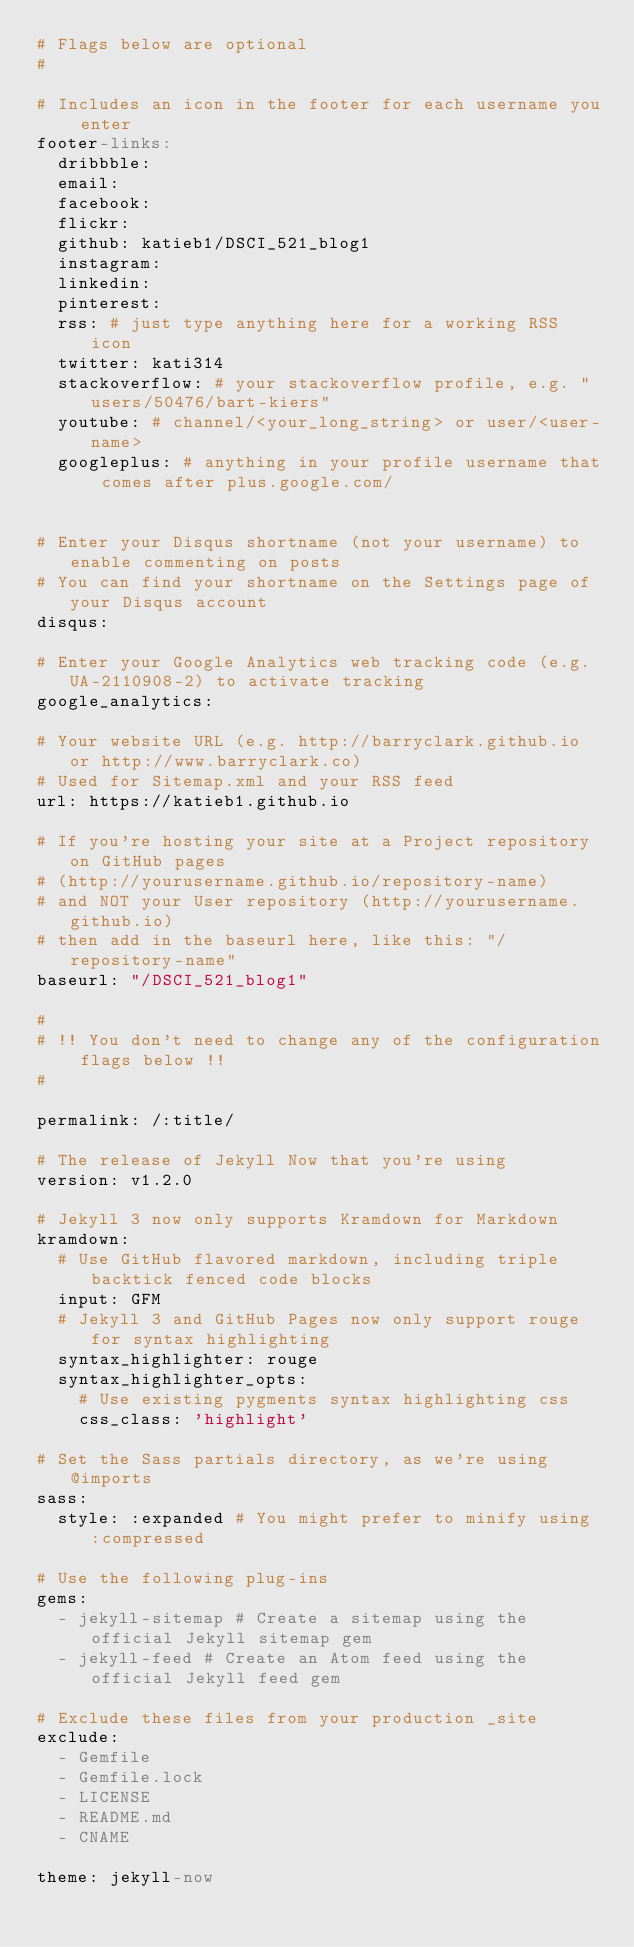<code> <loc_0><loc_0><loc_500><loc_500><_YAML_># Flags below are optional
#

# Includes an icon in the footer for each username you enter
footer-links:
  dribbble:
  email:
  facebook:
  flickr:
  github: katieb1/DSCI_521_blog1
  instagram:
  linkedin:
  pinterest:
  rss: # just type anything here for a working RSS icon
  twitter: kati314
  stackoverflow: # your stackoverflow profile, e.g. "users/50476/bart-kiers"
  youtube: # channel/<your_long_string> or user/<user-name>
  googleplus: # anything in your profile username that comes after plus.google.com/


# Enter your Disqus shortname (not your username) to enable commenting on posts
# You can find your shortname on the Settings page of your Disqus account
disqus:

# Enter your Google Analytics web tracking code (e.g. UA-2110908-2) to activate tracking
google_analytics:

# Your website URL (e.g. http://barryclark.github.io or http://www.barryclark.co)
# Used for Sitemap.xml and your RSS feed
url: https://katieb1.github.io

# If you're hosting your site at a Project repository on GitHub pages
# (http://yourusername.github.io/repository-name)
# and NOT your User repository (http://yourusername.github.io)
# then add in the baseurl here, like this: "/repository-name"
baseurl: "/DSCI_521_blog1"

#
# !! You don't need to change any of the configuration flags below !!
#

permalink: /:title/

# The release of Jekyll Now that you're using
version: v1.2.0

# Jekyll 3 now only supports Kramdown for Markdown
kramdown:
  # Use GitHub flavored markdown, including triple backtick fenced code blocks
  input: GFM
  # Jekyll 3 and GitHub Pages now only support rouge for syntax highlighting
  syntax_highlighter: rouge
  syntax_highlighter_opts:
    # Use existing pygments syntax highlighting css
    css_class: 'highlight'

# Set the Sass partials directory, as we're using @imports
sass:
  style: :expanded # You might prefer to minify using :compressed

# Use the following plug-ins
gems:
  - jekyll-sitemap # Create a sitemap using the official Jekyll sitemap gem
  - jekyll-feed # Create an Atom feed using the official Jekyll feed gem

# Exclude these files from your production _site
exclude:
  - Gemfile
  - Gemfile.lock
  - LICENSE
  - README.md
  - CNAME

theme: jekyll-now
</code> 